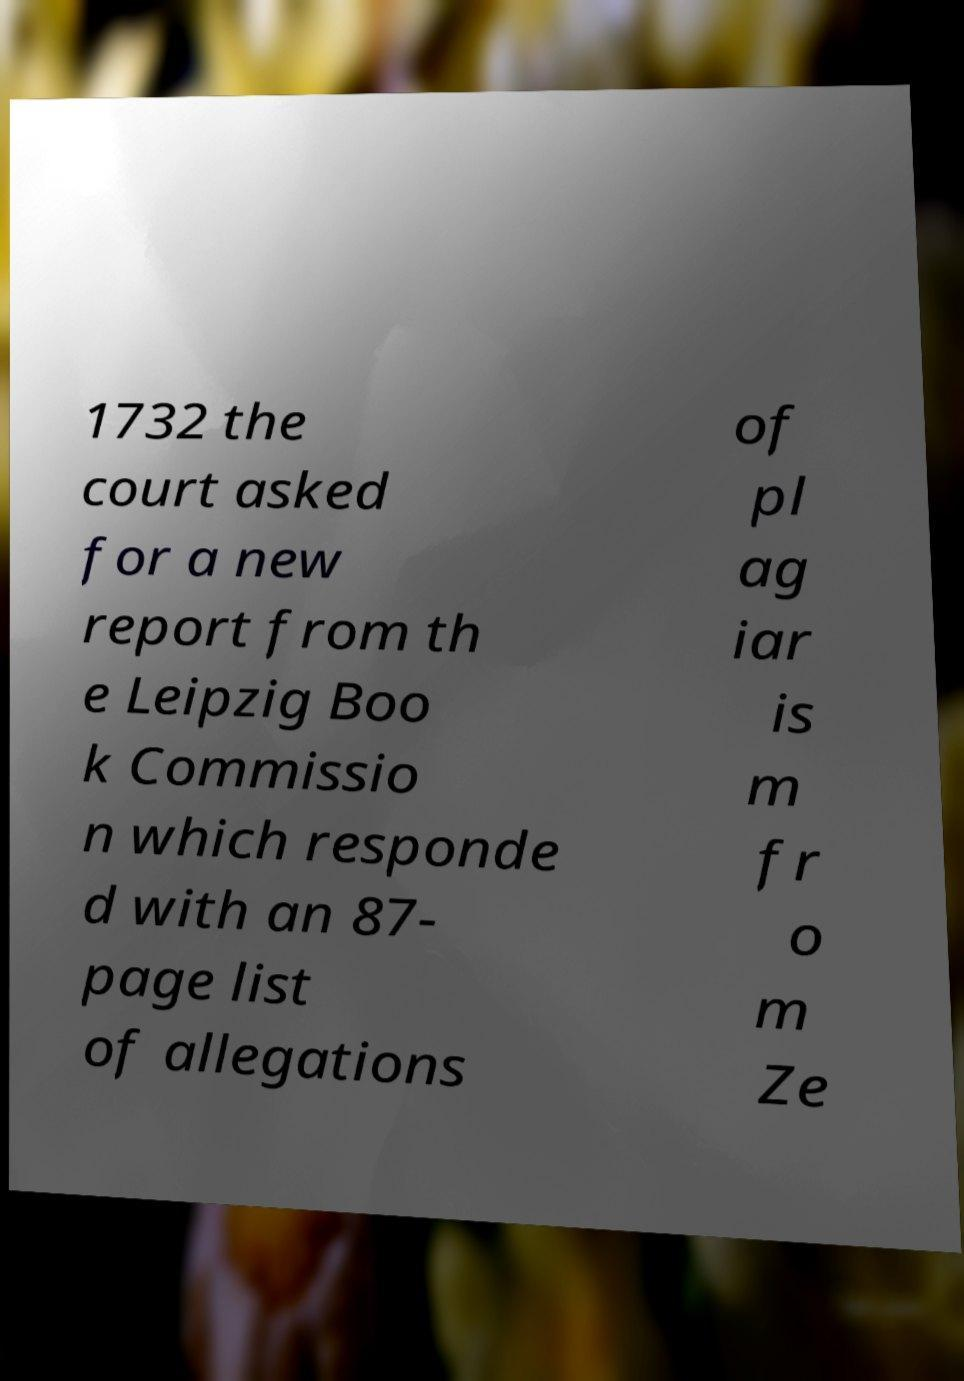Can you accurately transcribe the text from the provided image for me? 1732 the court asked for a new report from th e Leipzig Boo k Commissio n which responde d with an 87- page list of allegations of pl ag iar is m fr o m Ze 